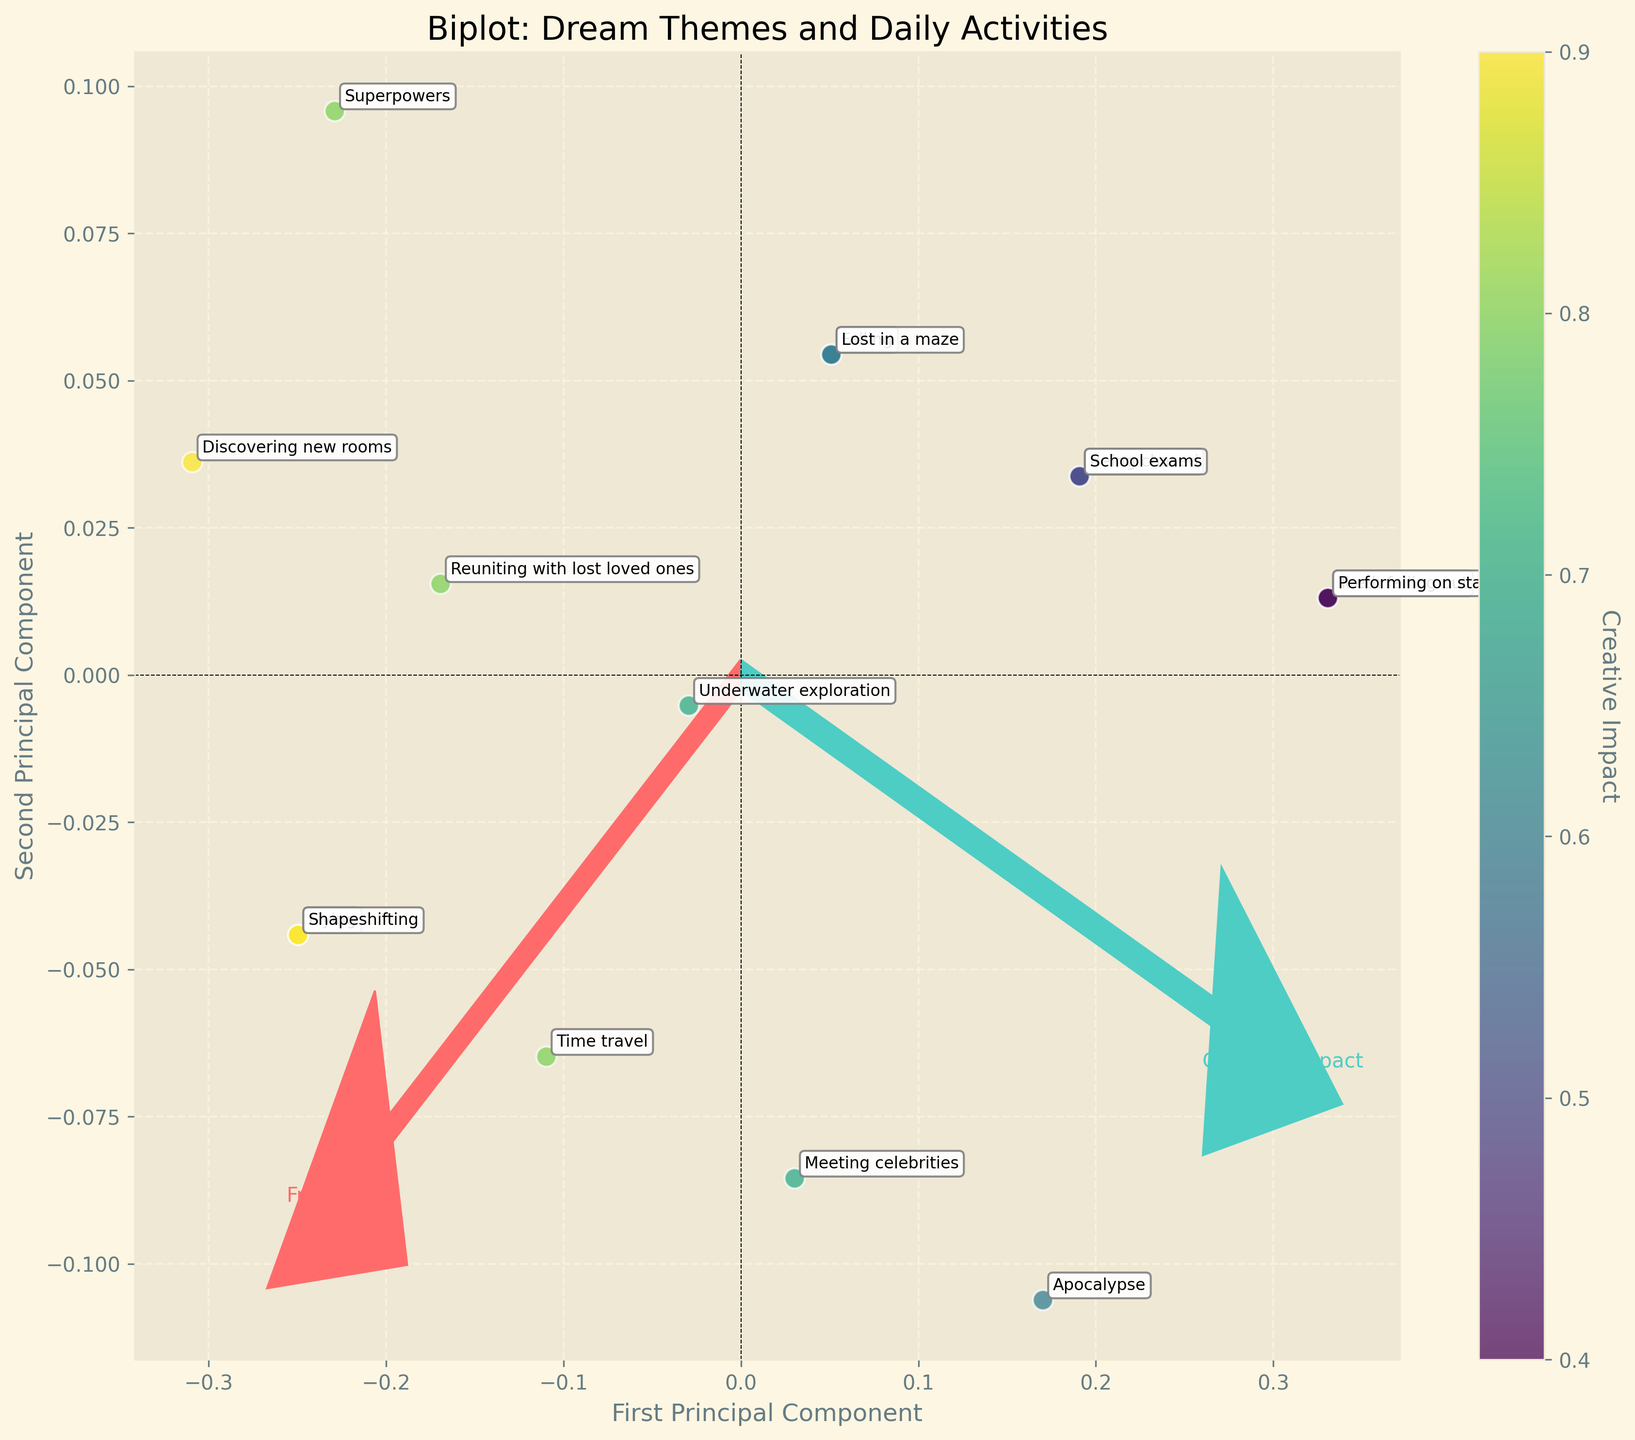How many dream themes are depicted in the plot? To determine the number of dream themes, count the labeled data points in the figure. Each point represents a distinct dream theme.
Answer: 15 What is the title of the plot? The title of the plot is usually displayed at the top, center of the figure.
Answer: Biplot: Dream Themes and Daily Activities Which dream theme is positioned furthest to the right along the first principal component? Look at the data points scattered along the x-axis (first principal component) and identify the label of the point furthest to the right.
Answer: Superpowers Which daily activity is associated with the dream theme "Time travel"? Locate the label "Time travel" on the plot, then refer to the associated daily activity mentioned in the data set.
Answer: Research How are dream themes with high creative impact generally positioned on the plot? The color of the data points represents creative impact. Points with higher creative impact are represented by brighter colors on the viridis colormap. Notice their position on the plot.
Answer: Towards the top-right Between the dream themes "Flying" and "Being chased", which one scored higher in frequency? Check the positions and colors of the points labeled "Flying" and "Being chased". Refer to the axis projections to compare their frequency scores.
Answer: Flying What is the commonality in the position of dream themes with low creative impact scores? Identify the color gradient that represents low creative impact on the colormap and see where those points are clustered on the plot.
Answer: Bottom-left Which dream theme is closest to the origin (0,0) on the plot? Locate the data point closest to the intersection of the x-axis and y-axis (origin) and identify its label.
Answer: Performing on stage Which feature vector (arrow) is longer, indicating a more significant variance explained? Compare the lengths of the two vectors (arrows) starting from the origin and extending outward, representing the two principal components.
Answer: Frequency Are the dream themes "Discovering new rooms" and "Superpowers" similar in their positioning on both principal components? Compare the positions of "Discovering new rooms" and "Superpowers" in terms of their projection on both axes. If they are close by, their positions are similar.
Answer: Yes 